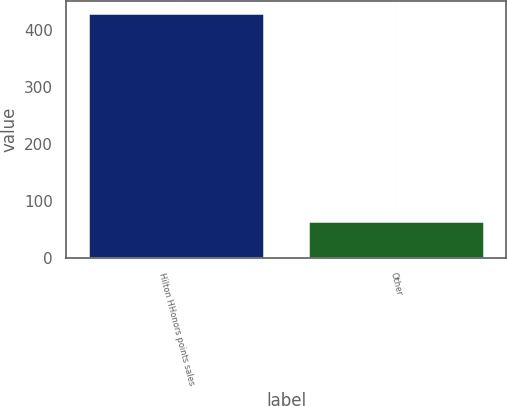Convert chart. <chart><loc_0><loc_0><loc_500><loc_500><bar_chart><fcel>Hilton HHonors points sales<fcel>Other<nl><fcel>429<fcel>66<nl></chart> 